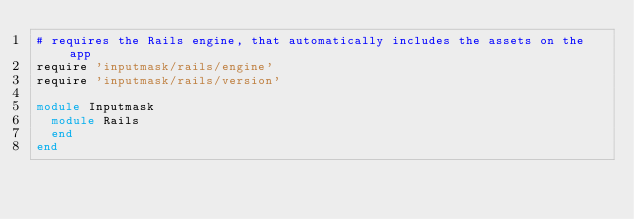Convert code to text. <code><loc_0><loc_0><loc_500><loc_500><_Ruby_># requires the Rails engine, that automatically includes the assets on the app
require 'inputmask/rails/engine'
require 'inputmask/rails/version'

module Inputmask
  module Rails
  end
end
</code> 